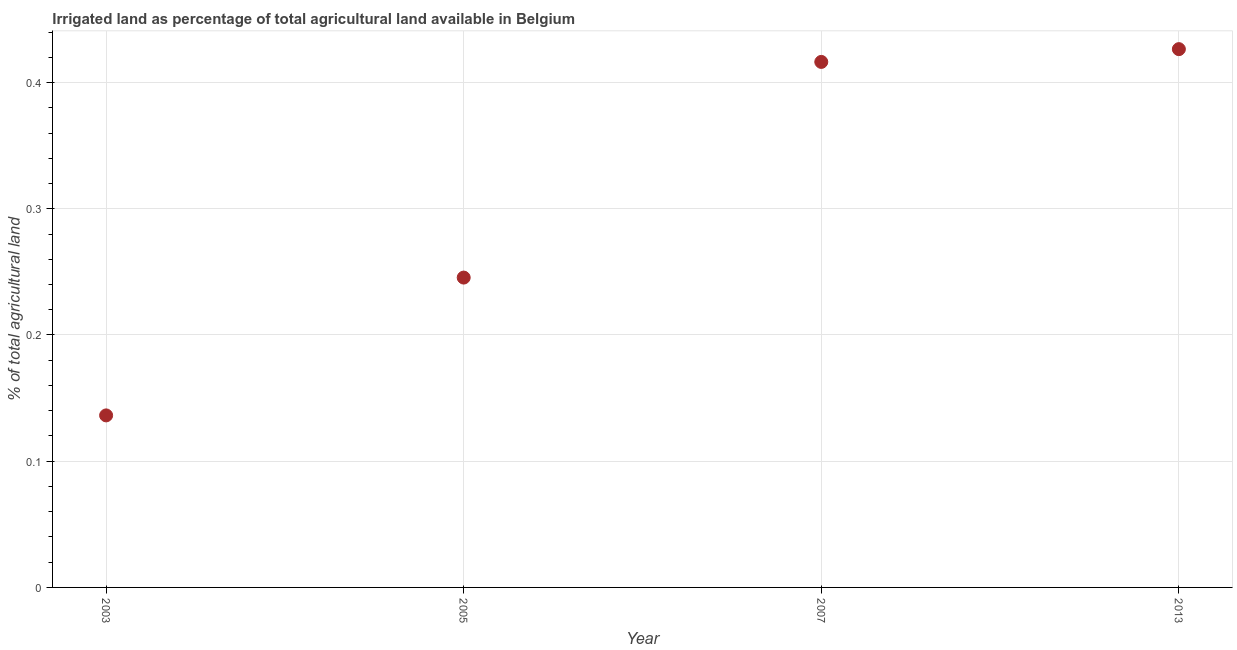What is the percentage of agricultural irrigated land in 2003?
Make the answer very short. 0.14. Across all years, what is the maximum percentage of agricultural irrigated land?
Provide a succinct answer. 0.43. Across all years, what is the minimum percentage of agricultural irrigated land?
Your answer should be compact. 0.14. In which year was the percentage of agricultural irrigated land minimum?
Give a very brief answer. 2003. What is the sum of the percentage of agricultural irrigated land?
Your response must be concise. 1.22. What is the difference between the percentage of agricultural irrigated land in 2003 and 2007?
Your answer should be very brief. -0.28. What is the average percentage of agricultural irrigated land per year?
Your answer should be very brief. 0.31. What is the median percentage of agricultural irrigated land?
Offer a very short reply. 0.33. In how many years, is the percentage of agricultural irrigated land greater than 0.12000000000000001 %?
Offer a terse response. 4. What is the ratio of the percentage of agricultural irrigated land in 2003 to that in 2013?
Keep it short and to the point. 0.32. Is the difference between the percentage of agricultural irrigated land in 2003 and 2005 greater than the difference between any two years?
Give a very brief answer. No. What is the difference between the highest and the second highest percentage of agricultural irrigated land?
Offer a very short reply. 0.01. What is the difference between the highest and the lowest percentage of agricultural irrigated land?
Give a very brief answer. 0.29. In how many years, is the percentage of agricultural irrigated land greater than the average percentage of agricultural irrigated land taken over all years?
Offer a very short reply. 2. How many dotlines are there?
Ensure brevity in your answer.  1. What is the difference between two consecutive major ticks on the Y-axis?
Your answer should be very brief. 0.1. Does the graph contain grids?
Offer a terse response. Yes. What is the title of the graph?
Give a very brief answer. Irrigated land as percentage of total agricultural land available in Belgium. What is the label or title of the X-axis?
Make the answer very short. Year. What is the label or title of the Y-axis?
Your answer should be compact. % of total agricultural land. What is the % of total agricultural land in 2003?
Provide a short and direct response. 0.14. What is the % of total agricultural land in 2005?
Your answer should be very brief. 0.25. What is the % of total agricultural land in 2007?
Offer a terse response. 0.42. What is the % of total agricultural land in 2013?
Offer a terse response. 0.43. What is the difference between the % of total agricultural land in 2003 and 2005?
Offer a terse response. -0.11. What is the difference between the % of total agricultural land in 2003 and 2007?
Offer a very short reply. -0.28. What is the difference between the % of total agricultural land in 2003 and 2013?
Offer a terse response. -0.29. What is the difference between the % of total agricultural land in 2005 and 2007?
Keep it short and to the point. -0.17. What is the difference between the % of total agricultural land in 2005 and 2013?
Make the answer very short. -0.18. What is the difference between the % of total agricultural land in 2007 and 2013?
Provide a short and direct response. -0.01. What is the ratio of the % of total agricultural land in 2003 to that in 2005?
Your answer should be very brief. 0.56. What is the ratio of the % of total agricultural land in 2003 to that in 2007?
Offer a terse response. 0.33. What is the ratio of the % of total agricultural land in 2003 to that in 2013?
Keep it short and to the point. 0.32. What is the ratio of the % of total agricultural land in 2005 to that in 2007?
Ensure brevity in your answer.  0.59. What is the ratio of the % of total agricultural land in 2005 to that in 2013?
Your answer should be very brief. 0.58. 